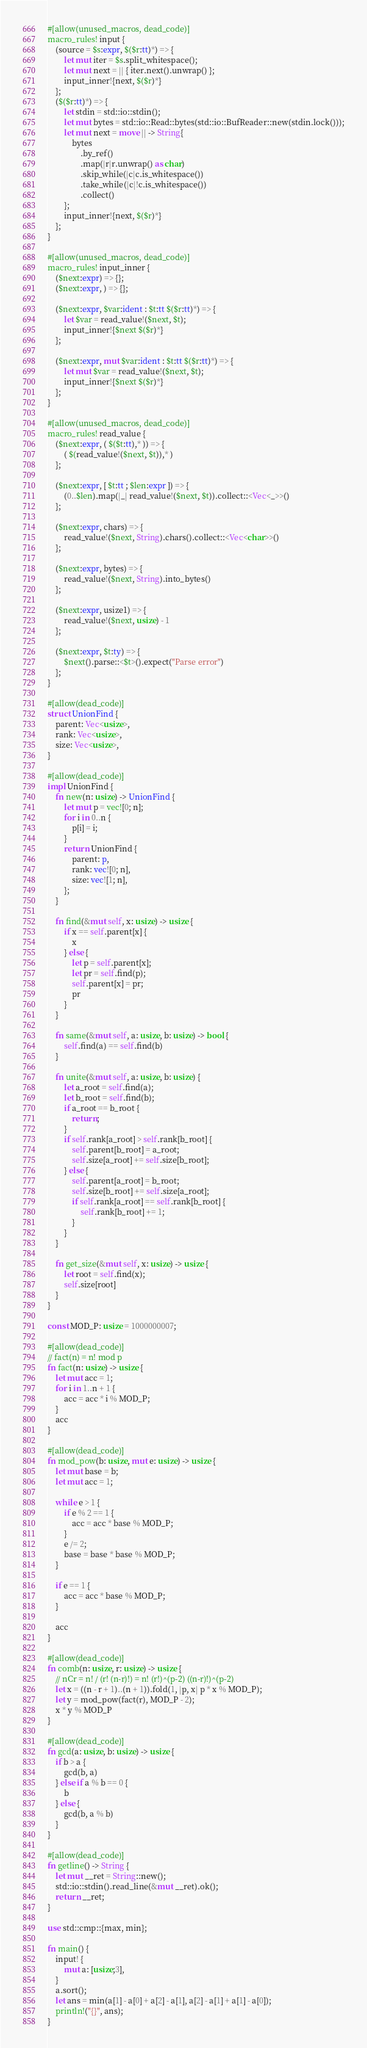Convert code to text. <code><loc_0><loc_0><loc_500><loc_500><_Rust_>#[allow(unused_macros, dead_code)]
macro_rules! input {
    (source = $s:expr, $($r:tt)*) => {
        let mut iter = $s.split_whitespace();
        let mut next = || { iter.next().unwrap() };
        input_inner!{next, $($r)*}
    };
    ($($r:tt)*) => {
        let stdin = std::io::stdin();
        let mut bytes = std::io::Read::bytes(std::io::BufReader::new(stdin.lock()));
        let mut next = move || -> String{
            bytes
                .by_ref()
                .map(|r|r.unwrap() as char)
                .skip_while(|c|c.is_whitespace())
                .take_while(|c|!c.is_whitespace())
                .collect()
        };
        input_inner!{next, $($r)*}
    };
}

#[allow(unused_macros, dead_code)]
macro_rules! input_inner {
    ($next:expr) => {};
    ($next:expr, ) => {};

    ($next:expr, $var:ident : $t:tt $($r:tt)*) => {
        let $var = read_value!($next, $t);
        input_inner!{$next $($r)*}
    };

    ($next:expr, mut $var:ident : $t:tt $($r:tt)*) => {
        let mut $var = read_value!($next, $t);
        input_inner!{$next $($r)*}
    };
}

#[allow(unused_macros, dead_code)]
macro_rules! read_value {
    ($next:expr, ( $($t:tt),* )) => {
        ( $(read_value!($next, $t)),* )
    };

    ($next:expr, [ $t:tt ; $len:expr ]) => {
        (0..$len).map(|_| read_value!($next, $t)).collect::<Vec<_>>()
    };

    ($next:expr, chars) => {
        read_value!($next, String).chars().collect::<Vec<char>>()
    };

    ($next:expr, bytes) => {
        read_value!($next, String).into_bytes()
    };

    ($next:expr, usize1) => {
        read_value!($next, usize) - 1
    };

    ($next:expr, $t:ty) => {
        $next().parse::<$t>().expect("Parse error")
    };
}

#[allow(dead_code)]
struct UnionFind {
    parent: Vec<usize>,
    rank: Vec<usize>,
    size: Vec<usize>,
}

#[allow(dead_code)]
impl UnionFind {
    fn new(n: usize) -> UnionFind {
        let mut p = vec![0; n];
        for i in 0..n {
            p[i] = i;
        }
        return UnionFind {
            parent: p,
            rank: vec![0; n],
            size: vec![1; n],
        };
    }

    fn find(&mut self, x: usize) -> usize {
        if x == self.parent[x] {
            x
        } else {
            let p = self.parent[x];
            let pr = self.find(p);
            self.parent[x] = pr;
            pr
        }
    }

    fn same(&mut self, a: usize, b: usize) -> bool {
        self.find(a) == self.find(b)
    }

    fn unite(&mut self, a: usize, b: usize) {
        let a_root = self.find(a);
        let b_root = self.find(b);
        if a_root == b_root {
            return;
        }
        if self.rank[a_root] > self.rank[b_root] {
            self.parent[b_root] = a_root;
            self.size[a_root] += self.size[b_root];
        } else {
            self.parent[a_root] = b_root;
            self.size[b_root] += self.size[a_root];
            if self.rank[a_root] == self.rank[b_root] {
                self.rank[b_root] += 1;
            }
        }
    }

    fn get_size(&mut self, x: usize) -> usize {
        let root = self.find(x);
        self.size[root]
    }
}

const MOD_P: usize = 1000000007;

#[allow(dead_code)]
// fact(n) = n! mod p
fn fact(n: usize) -> usize {
    let mut acc = 1;
    for i in 1..n + 1 {
        acc = acc * i % MOD_P;
    }
    acc
}

#[allow(dead_code)]
fn mod_pow(b: usize, mut e: usize) -> usize {
    let mut base = b;
    let mut acc = 1;

    while e > 1 {
        if e % 2 == 1 {
            acc = acc * base % MOD_P;
        }
        e /= 2;
        base = base * base % MOD_P;
    }

    if e == 1 {
        acc = acc * base % MOD_P;
    }

    acc
}

#[allow(dead_code)]
fn comb(n: usize, r: usize) -> usize {
    // nCr = n! / (r! (n-r)!) = n! (r!)^(p-2) ((n-r)!)^(p-2)
    let x = ((n - r + 1)..(n + 1)).fold(1, |p, x| p * x % MOD_P);
    let y = mod_pow(fact(r), MOD_P - 2);
    x * y % MOD_P
}

#[allow(dead_code)]
fn gcd(a: usize, b: usize) -> usize {
    if b > a {
        gcd(b, a)
    } else if a % b == 0 {
        b
    } else {
        gcd(b, a % b)
    }
}

#[allow(dead_code)]
fn getline() -> String {
    let mut __ret = String::new();
    std::io::stdin().read_line(&mut __ret).ok();
    return __ret;
}

use std::cmp::{max, min};

fn main() {
    input! {
        mut a: [usize;3],
    }
    a.sort();
    let ans = min(a[1] - a[0] + a[2] - a[1], a[2] - a[1] + a[1] - a[0]);
    println!("{}", ans);
}
</code> 